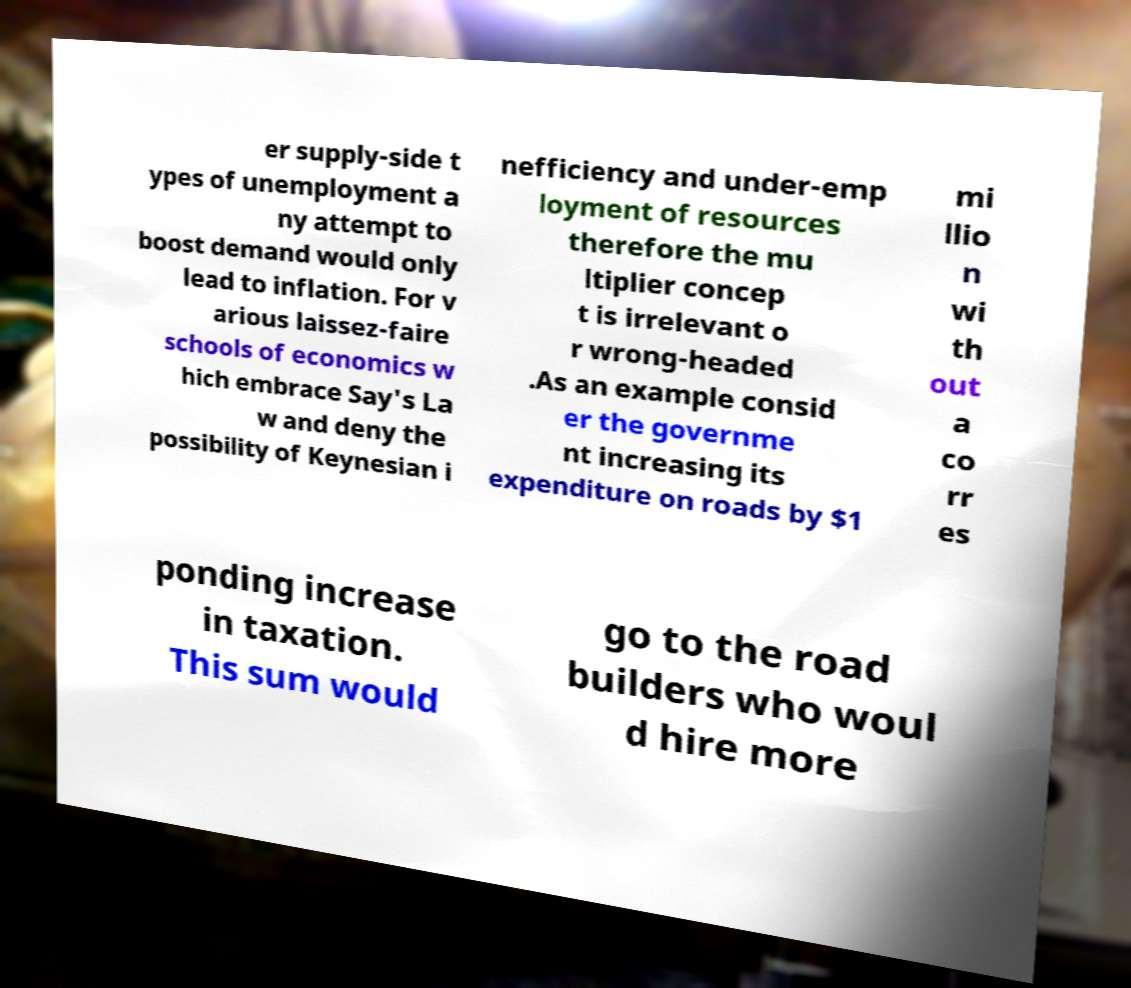There's text embedded in this image that I need extracted. Can you transcribe it verbatim? er supply-side t ypes of unemployment a ny attempt to boost demand would only lead to inflation. For v arious laissez-faire schools of economics w hich embrace Say's La w and deny the possibility of Keynesian i nefficiency and under-emp loyment of resources therefore the mu ltiplier concep t is irrelevant o r wrong-headed .As an example consid er the governme nt increasing its expenditure on roads by $1 mi llio n wi th out a co rr es ponding increase in taxation. This sum would go to the road builders who woul d hire more 